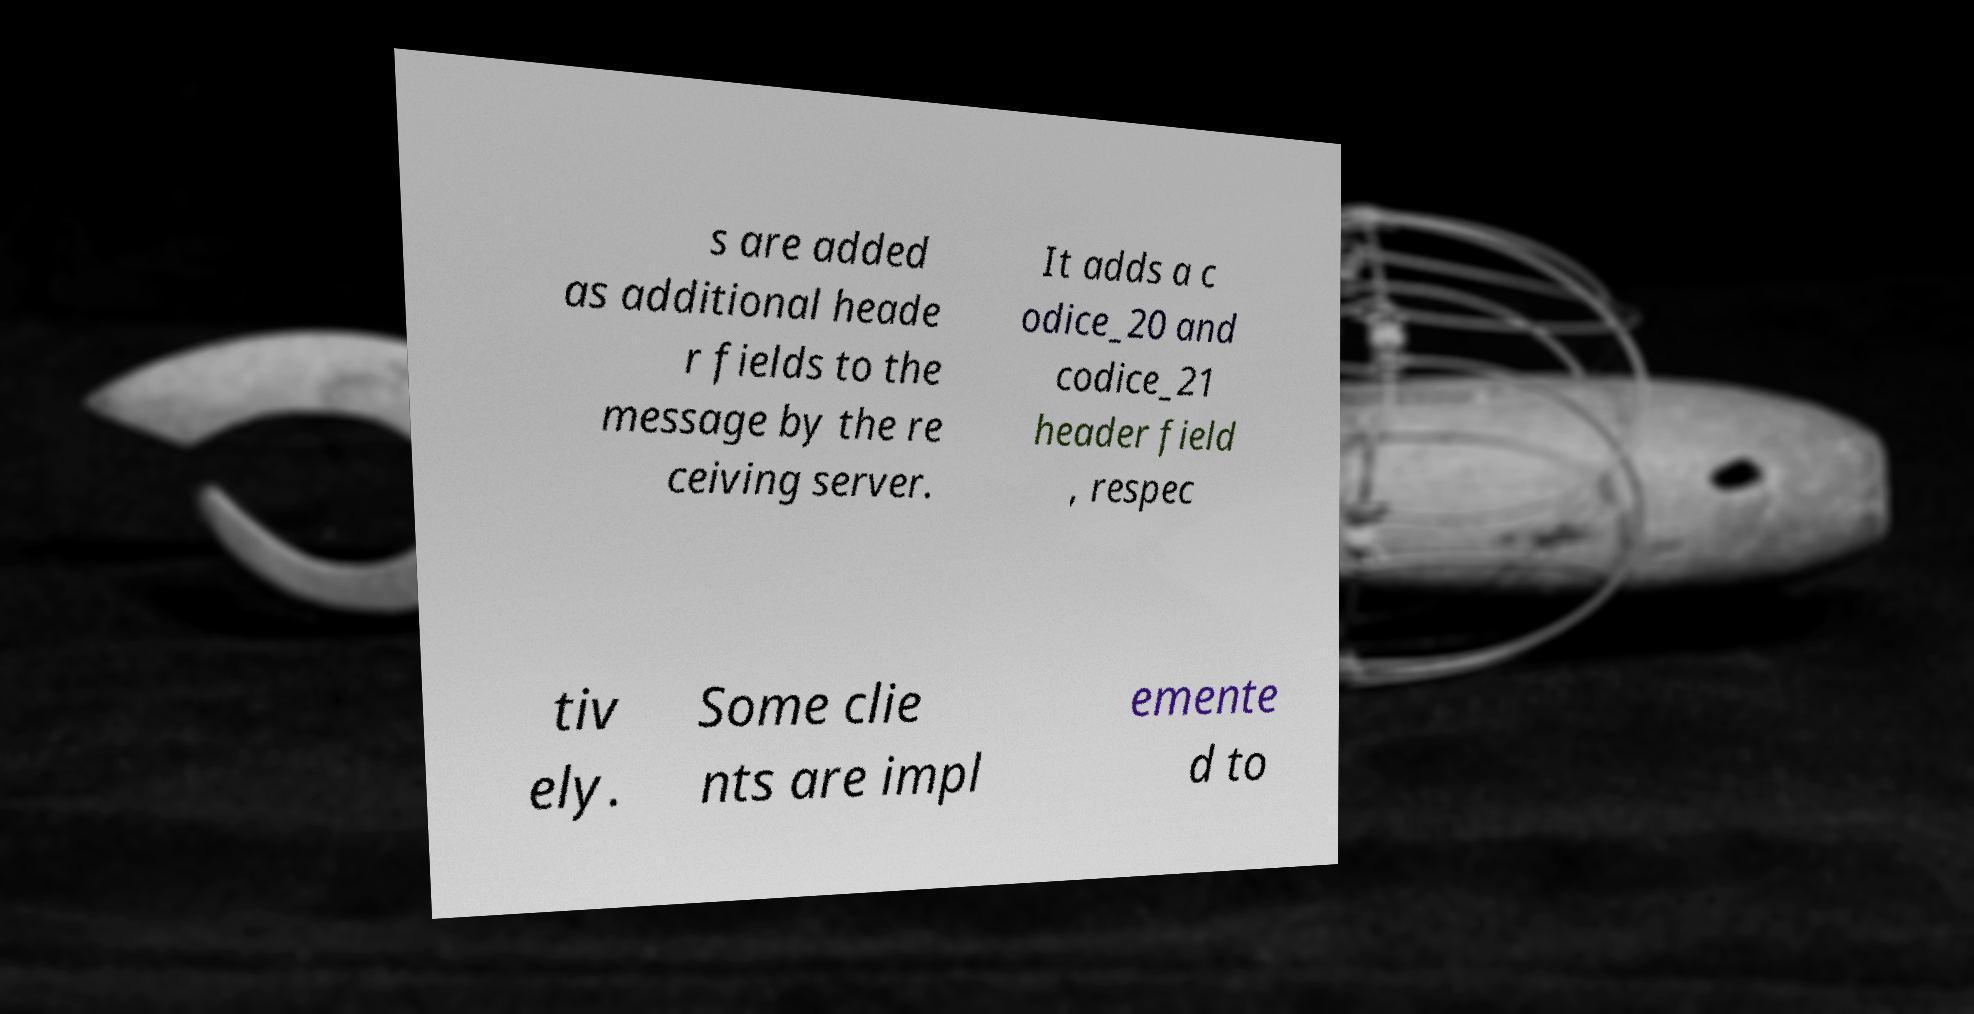For documentation purposes, I need the text within this image transcribed. Could you provide that? s are added as additional heade r fields to the message by the re ceiving server. It adds a c odice_20 and codice_21 header field , respec tiv ely. Some clie nts are impl emente d to 